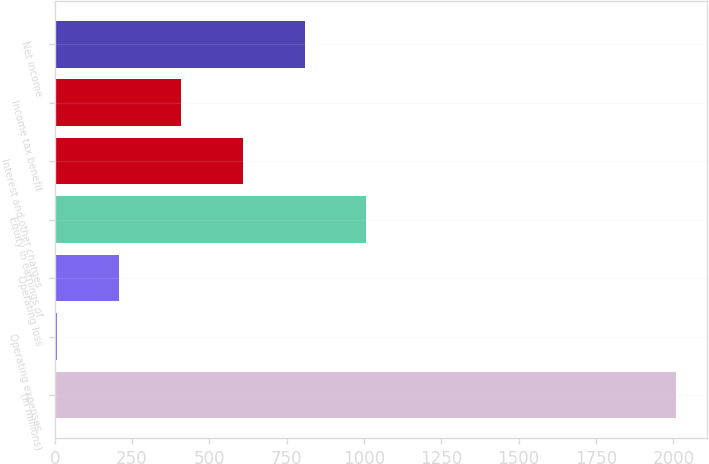<chart> <loc_0><loc_0><loc_500><loc_500><bar_chart><fcel>(In millions)<fcel>Operating expenses<fcel>Operating loss<fcel>Equity in earnings of<fcel>Interest and other charges<fcel>Income tax benefit<fcel>Net income<nl><fcel>2007<fcel>8<fcel>207.9<fcel>1007.5<fcel>607.7<fcel>407.8<fcel>807.6<nl></chart> 